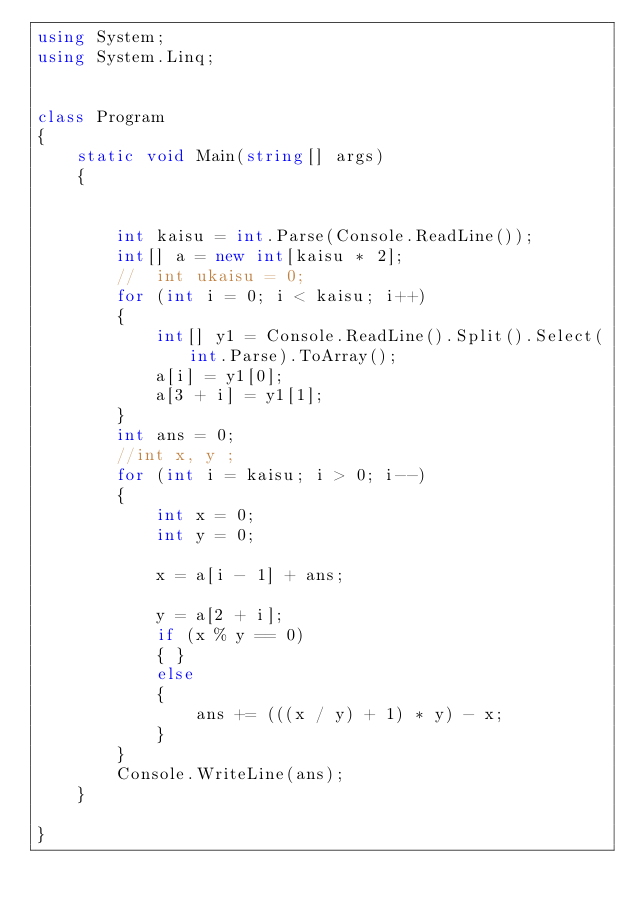Convert code to text. <code><loc_0><loc_0><loc_500><loc_500><_C#_>using System;
using System.Linq;


class Program
{
    static void Main(string[] args)
    {


        int kaisu = int.Parse(Console.ReadLine());
        int[] a = new int[kaisu * 2];
        //  int ukaisu = 0;
        for (int i = 0; i < kaisu; i++)
        {
            int[] y1 = Console.ReadLine().Split().Select(int.Parse).ToArray();
            a[i] = y1[0];
            a[3 + i] = y1[1];
        }
        int ans = 0;
        //int x, y ;
        for (int i = kaisu; i > 0; i--)
        {
            int x = 0;
            int y = 0;

            x = a[i - 1] + ans;

            y = a[2 + i];
            if (x % y == 0)
            { }
            else
            {
                ans += (((x / y) + 1) * y) - x;
            }
        }
        Console.WriteLine(ans);
    }

}</code> 